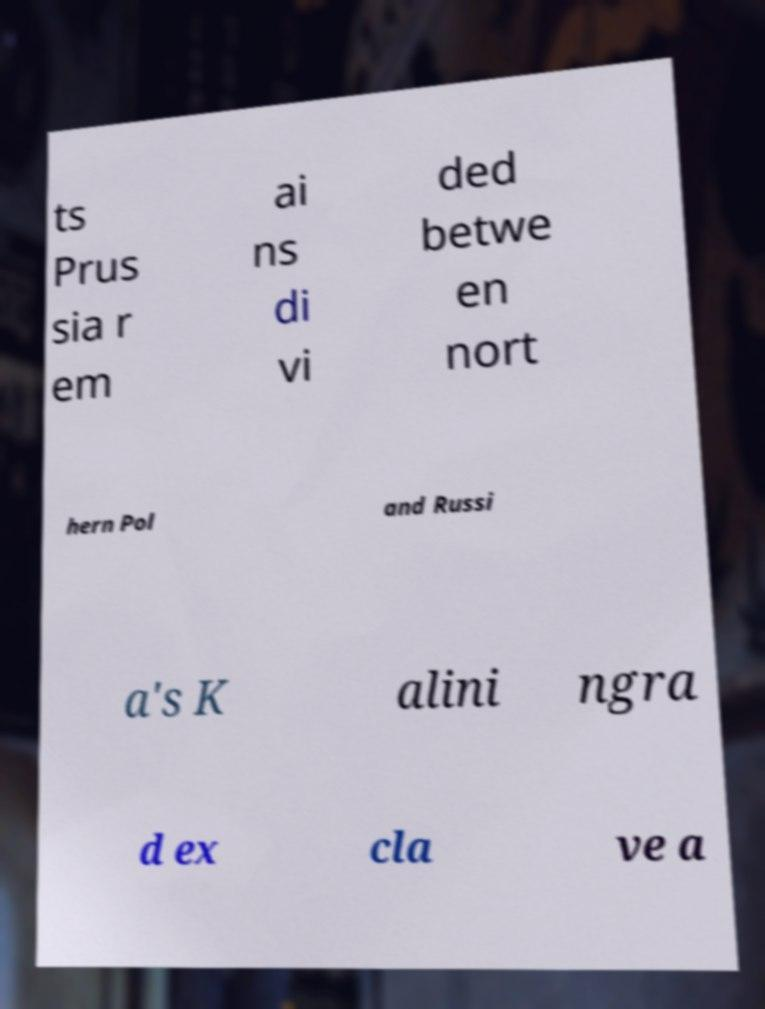Could you assist in decoding the text presented in this image and type it out clearly? ts Prus sia r em ai ns di vi ded betwe en nort hern Pol and Russi a's K alini ngra d ex cla ve a 